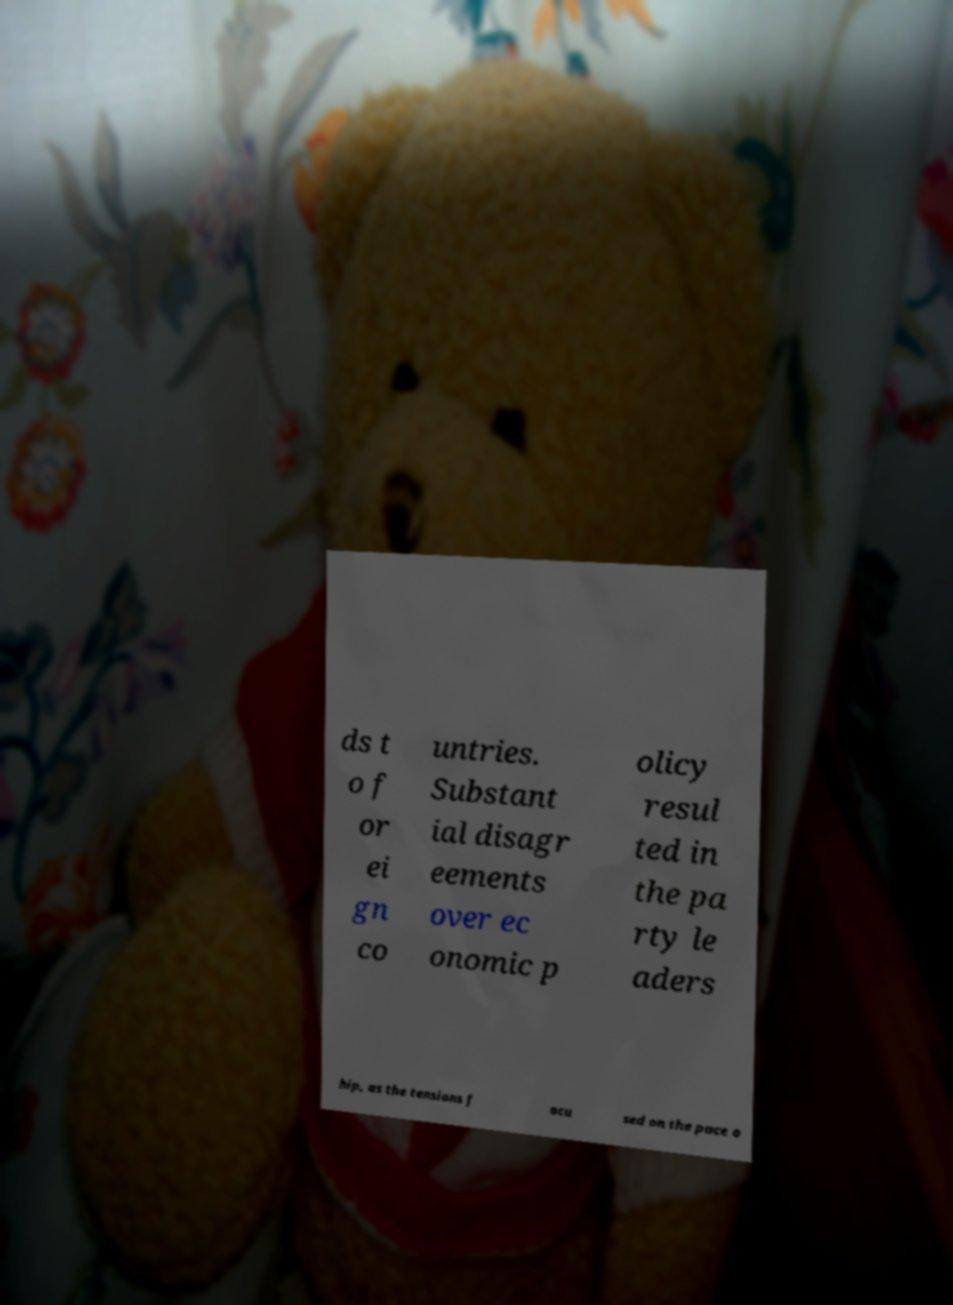Can you read and provide the text displayed in the image?This photo seems to have some interesting text. Can you extract and type it out for me? ds t o f or ei gn co untries. Substant ial disagr eements over ec onomic p olicy resul ted in the pa rty le aders hip, as the tensions f ocu sed on the pace o 